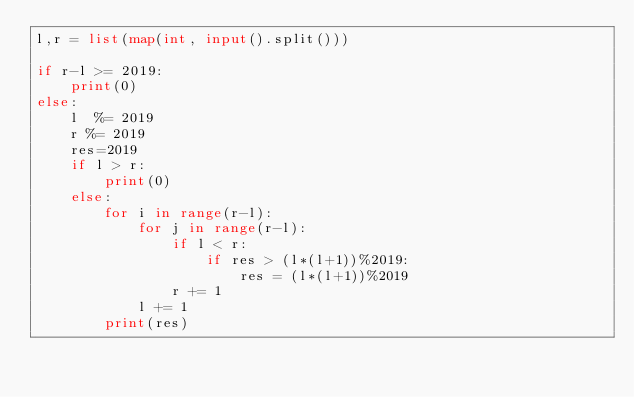Convert code to text. <code><loc_0><loc_0><loc_500><loc_500><_Python_>l,r = list(map(int, input().split())) 

if r-l >= 2019:
    print(0)
else:
    l  %= 2019
    r %= 2019
    res=2019
    if l > r:
        print(0)
    else:
        for i in range(r-l):
            for j in range(r-l):
                if l < r:
                    if res > (l*(l+1))%2019:
                        res = (l*(l+1))%2019
                r += 1
            l += 1
        print(res)</code> 